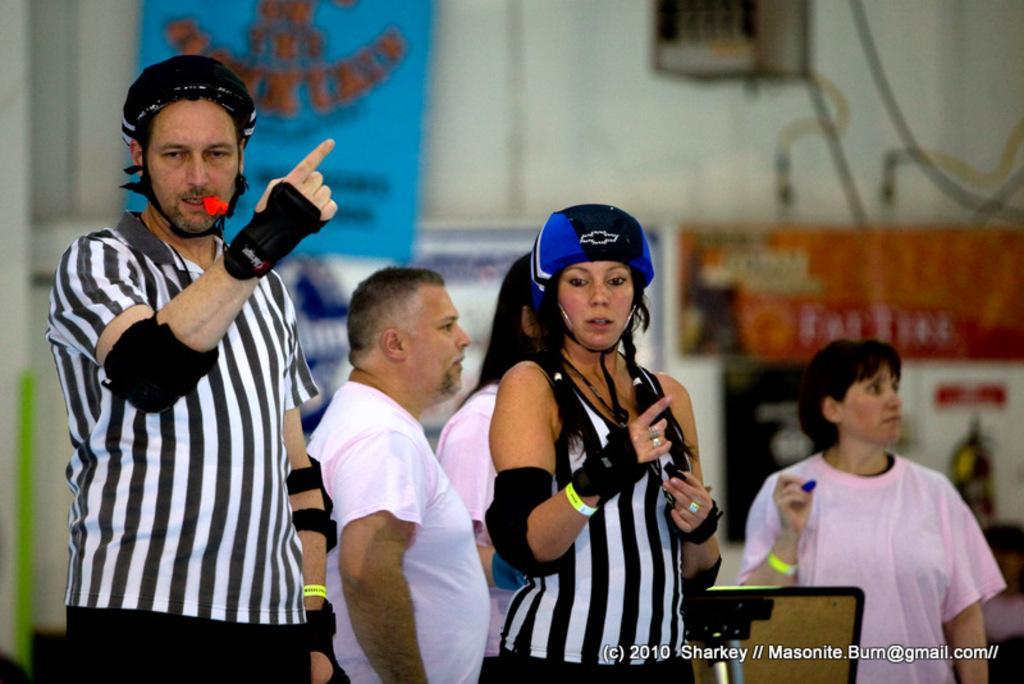In one or two sentences, can you explain what this image depicts? This picture seems to be clicked inside the hall. In the center we can see the group of people standing. In the background we can see the wall, window and we can see the text and some pictures on the banners and we can see the cables. In the bottom right corner there is a watermark on the image. 